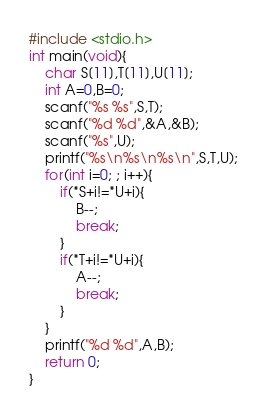<code> <loc_0><loc_0><loc_500><loc_500><_C_>#include <stdio.h>
int main(void){
    char S[11],T[11],U[11];
    int A=0,B=0;
    scanf("%s %s",S,T);
    scanf("%d %d",&A,&B);
    scanf("%s",U);
    printf("%s\n%s\n%s\n",S,T,U);
    for(int i=0; ; i++){
        if(*S+i!=*U+i){
            B--;
            break;
        }
        if(*T+i!=*U+i){
            A--;
            break;
        }
    }
    printf("%d %d",A,B);
    return 0;
}</code> 